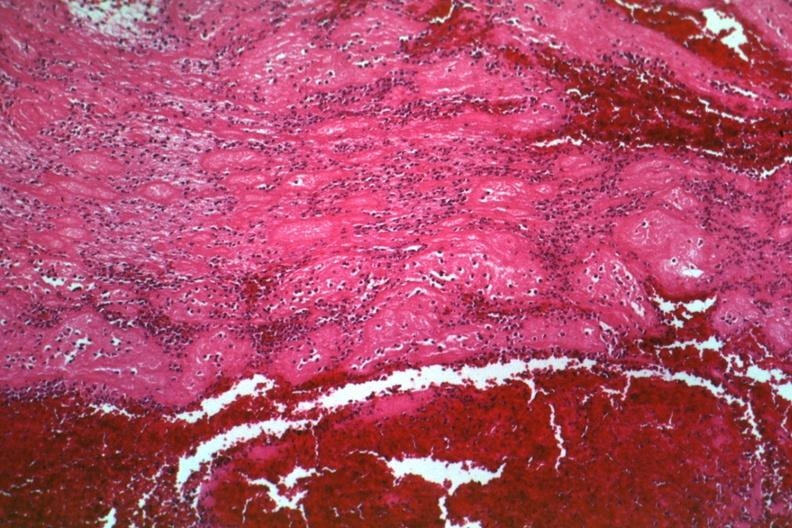does this image show typical structured thrombus quite good?
Answer the question using a single word or phrase. Yes 